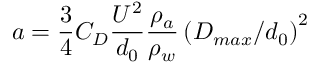Convert formula to latex. <formula><loc_0><loc_0><loc_500><loc_500>a = \frac { 3 } { 4 } C _ { D } \frac { U ^ { 2 } } { d _ { 0 } } \frac { \rho _ { a } } { \rho _ { w } } \left ( { D _ { \max } / d _ { 0 } } \right ) ^ { 2 }</formula> 